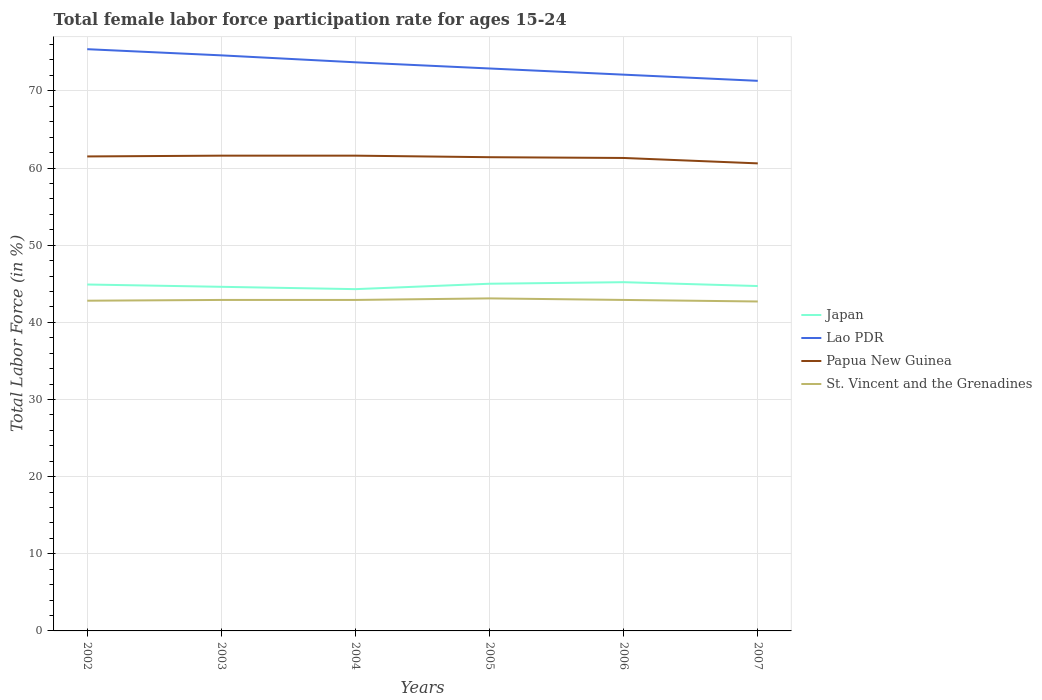How many different coloured lines are there?
Make the answer very short. 4. Across all years, what is the maximum female labor force participation rate in Japan?
Offer a very short reply. 44.3. What is the difference between the highest and the second highest female labor force participation rate in Lao PDR?
Keep it short and to the point. 4.1. Is the female labor force participation rate in St. Vincent and the Grenadines strictly greater than the female labor force participation rate in Papua New Guinea over the years?
Ensure brevity in your answer.  Yes. How many lines are there?
Ensure brevity in your answer.  4. Are the values on the major ticks of Y-axis written in scientific E-notation?
Your answer should be compact. No. Does the graph contain grids?
Make the answer very short. Yes. How many legend labels are there?
Provide a succinct answer. 4. How are the legend labels stacked?
Your answer should be very brief. Vertical. What is the title of the graph?
Offer a terse response. Total female labor force participation rate for ages 15-24. Does "Oman" appear as one of the legend labels in the graph?
Your answer should be very brief. No. What is the Total Labor Force (in %) of Japan in 2002?
Ensure brevity in your answer.  44.9. What is the Total Labor Force (in %) in Lao PDR in 2002?
Your answer should be very brief. 75.4. What is the Total Labor Force (in %) in Papua New Guinea in 2002?
Offer a very short reply. 61.5. What is the Total Labor Force (in %) in St. Vincent and the Grenadines in 2002?
Keep it short and to the point. 42.8. What is the Total Labor Force (in %) in Japan in 2003?
Make the answer very short. 44.6. What is the Total Labor Force (in %) of Lao PDR in 2003?
Ensure brevity in your answer.  74.6. What is the Total Labor Force (in %) in Papua New Guinea in 2003?
Offer a very short reply. 61.6. What is the Total Labor Force (in %) of St. Vincent and the Grenadines in 2003?
Offer a terse response. 42.9. What is the Total Labor Force (in %) of Japan in 2004?
Provide a short and direct response. 44.3. What is the Total Labor Force (in %) of Lao PDR in 2004?
Offer a very short reply. 73.7. What is the Total Labor Force (in %) in Papua New Guinea in 2004?
Provide a short and direct response. 61.6. What is the Total Labor Force (in %) in St. Vincent and the Grenadines in 2004?
Your answer should be compact. 42.9. What is the Total Labor Force (in %) in Japan in 2005?
Provide a succinct answer. 45. What is the Total Labor Force (in %) in Lao PDR in 2005?
Offer a terse response. 72.9. What is the Total Labor Force (in %) in Papua New Guinea in 2005?
Keep it short and to the point. 61.4. What is the Total Labor Force (in %) in St. Vincent and the Grenadines in 2005?
Your answer should be very brief. 43.1. What is the Total Labor Force (in %) of Japan in 2006?
Offer a very short reply. 45.2. What is the Total Labor Force (in %) in Lao PDR in 2006?
Keep it short and to the point. 72.1. What is the Total Labor Force (in %) in Papua New Guinea in 2006?
Make the answer very short. 61.3. What is the Total Labor Force (in %) of St. Vincent and the Grenadines in 2006?
Provide a succinct answer. 42.9. What is the Total Labor Force (in %) of Japan in 2007?
Offer a terse response. 44.7. What is the Total Labor Force (in %) of Lao PDR in 2007?
Offer a very short reply. 71.3. What is the Total Labor Force (in %) in Papua New Guinea in 2007?
Ensure brevity in your answer.  60.6. What is the Total Labor Force (in %) of St. Vincent and the Grenadines in 2007?
Your answer should be compact. 42.7. Across all years, what is the maximum Total Labor Force (in %) in Japan?
Your response must be concise. 45.2. Across all years, what is the maximum Total Labor Force (in %) in Lao PDR?
Offer a terse response. 75.4. Across all years, what is the maximum Total Labor Force (in %) in Papua New Guinea?
Keep it short and to the point. 61.6. Across all years, what is the maximum Total Labor Force (in %) in St. Vincent and the Grenadines?
Offer a very short reply. 43.1. Across all years, what is the minimum Total Labor Force (in %) of Japan?
Offer a terse response. 44.3. Across all years, what is the minimum Total Labor Force (in %) in Lao PDR?
Make the answer very short. 71.3. Across all years, what is the minimum Total Labor Force (in %) of Papua New Guinea?
Give a very brief answer. 60.6. Across all years, what is the minimum Total Labor Force (in %) in St. Vincent and the Grenadines?
Make the answer very short. 42.7. What is the total Total Labor Force (in %) of Japan in the graph?
Make the answer very short. 268.7. What is the total Total Labor Force (in %) in Lao PDR in the graph?
Give a very brief answer. 440. What is the total Total Labor Force (in %) of Papua New Guinea in the graph?
Offer a terse response. 368. What is the total Total Labor Force (in %) of St. Vincent and the Grenadines in the graph?
Keep it short and to the point. 257.3. What is the difference between the Total Labor Force (in %) of Japan in 2002 and that in 2003?
Keep it short and to the point. 0.3. What is the difference between the Total Labor Force (in %) in Lao PDR in 2002 and that in 2003?
Make the answer very short. 0.8. What is the difference between the Total Labor Force (in %) in St. Vincent and the Grenadines in 2002 and that in 2003?
Offer a very short reply. -0.1. What is the difference between the Total Labor Force (in %) of Japan in 2002 and that in 2004?
Ensure brevity in your answer.  0.6. What is the difference between the Total Labor Force (in %) in Lao PDR in 2002 and that in 2004?
Your answer should be compact. 1.7. What is the difference between the Total Labor Force (in %) of Papua New Guinea in 2002 and that in 2004?
Your answer should be very brief. -0.1. What is the difference between the Total Labor Force (in %) in Japan in 2002 and that in 2006?
Keep it short and to the point. -0.3. What is the difference between the Total Labor Force (in %) in Lao PDR in 2002 and that in 2006?
Offer a terse response. 3.3. What is the difference between the Total Labor Force (in %) of Papua New Guinea in 2002 and that in 2006?
Ensure brevity in your answer.  0.2. What is the difference between the Total Labor Force (in %) of Papua New Guinea in 2002 and that in 2007?
Ensure brevity in your answer.  0.9. What is the difference between the Total Labor Force (in %) in Japan in 2003 and that in 2004?
Give a very brief answer. 0.3. What is the difference between the Total Labor Force (in %) in Lao PDR in 2003 and that in 2004?
Offer a terse response. 0.9. What is the difference between the Total Labor Force (in %) in Papua New Guinea in 2003 and that in 2004?
Make the answer very short. 0. What is the difference between the Total Labor Force (in %) in St. Vincent and the Grenadines in 2003 and that in 2004?
Your answer should be compact. 0. What is the difference between the Total Labor Force (in %) in Japan in 2003 and that in 2005?
Give a very brief answer. -0.4. What is the difference between the Total Labor Force (in %) in Lao PDR in 2003 and that in 2005?
Your answer should be compact. 1.7. What is the difference between the Total Labor Force (in %) of Lao PDR in 2003 and that in 2006?
Provide a succinct answer. 2.5. What is the difference between the Total Labor Force (in %) in Papua New Guinea in 2003 and that in 2006?
Your answer should be compact. 0.3. What is the difference between the Total Labor Force (in %) of Japan in 2003 and that in 2007?
Provide a short and direct response. -0.1. What is the difference between the Total Labor Force (in %) of St. Vincent and the Grenadines in 2003 and that in 2007?
Provide a short and direct response. 0.2. What is the difference between the Total Labor Force (in %) in Japan in 2004 and that in 2005?
Ensure brevity in your answer.  -0.7. What is the difference between the Total Labor Force (in %) of Lao PDR in 2004 and that in 2005?
Offer a very short reply. 0.8. What is the difference between the Total Labor Force (in %) of Papua New Guinea in 2004 and that in 2005?
Provide a short and direct response. 0.2. What is the difference between the Total Labor Force (in %) in St. Vincent and the Grenadines in 2004 and that in 2005?
Ensure brevity in your answer.  -0.2. What is the difference between the Total Labor Force (in %) of Japan in 2004 and that in 2006?
Make the answer very short. -0.9. What is the difference between the Total Labor Force (in %) in Papua New Guinea in 2004 and that in 2006?
Keep it short and to the point. 0.3. What is the difference between the Total Labor Force (in %) in St. Vincent and the Grenadines in 2004 and that in 2006?
Your response must be concise. 0. What is the difference between the Total Labor Force (in %) of Japan in 2004 and that in 2007?
Offer a very short reply. -0.4. What is the difference between the Total Labor Force (in %) of St. Vincent and the Grenadines in 2004 and that in 2007?
Provide a short and direct response. 0.2. What is the difference between the Total Labor Force (in %) in Japan in 2005 and that in 2006?
Ensure brevity in your answer.  -0.2. What is the difference between the Total Labor Force (in %) of Papua New Guinea in 2005 and that in 2006?
Keep it short and to the point. 0.1. What is the difference between the Total Labor Force (in %) of St. Vincent and the Grenadines in 2005 and that in 2006?
Give a very brief answer. 0.2. What is the difference between the Total Labor Force (in %) of Japan in 2005 and that in 2007?
Make the answer very short. 0.3. What is the difference between the Total Labor Force (in %) of St. Vincent and the Grenadines in 2005 and that in 2007?
Provide a short and direct response. 0.4. What is the difference between the Total Labor Force (in %) of Japan in 2006 and that in 2007?
Your answer should be very brief. 0.5. What is the difference between the Total Labor Force (in %) of Japan in 2002 and the Total Labor Force (in %) of Lao PDR in 2003?
Offer a very short reply. -29.7. What is the difference between the Total Labor Force (in %) of Japan in 2002 and the Total Labor Force (in %) of Papua New Guinea in 2003?
Offer a very short reply. -16.7. What is the difference between the Total Labor Force (in %) of Japan in 2002 and the Total Labor Force (in %) of St. Vincent and the Grenadines in 2003?
Make the answer very short. 2. What is the difference between the Total Labor Force (in %) in Lao PDR in 2002 and the Total Labor Force (in %) in St. Vincent and the Grenadines in 2003?
Give a very brief answer. 32.5. What is the difference between the Total Labor Force (in %) of Papua New Guinea in 2002 and the Total Labor Force (in %) of St. Vincent and the Grenadines in 2003?
Keep it short and to the point. 18.6. What is the difference between the Total Labor Force (in %) in Japan in 2002 and the Total Labor Force (in %) in Lao PDR in 2004?
Your answer should be compact. -28.8. What is the difference between the Total Labor Force (in %) in Japan in 2002 and the Total Labor Force (in %) in Papua New Guinea in 2004?
Provide a short and direct response. -16.7. What is the difference between the Total Labor Force (in %) of Japan in 2002 and the Total Labor Force (in %) of St. Vincent and the Grenadines in 2004?
Provide a short and direct response. 2. What is the difference between the Total Labor Force (in %) in Lao PDR in 2002 and the Total Labor Force (in %) in Papua New Guinea in 2004?
Make the answer very short. 13.8. What is the difference between the Total Labor Force (in %) of Lao PDR in 2002 and the Total Labor Force (in %) of St. Vincent and the Grenadines in 2004?
Your response must be concise. 32.5. What is the difference between the Total Labor Force (in %) of Japan in 2002 and the Total Labor Force (in %) of Papua New Guinea in 2005?
Your answer should be compact. -16.5. What is the difference between the Total Labor Force (in %) in Lao PDR in 2002 and the Total Labor Force (in %) in Papua New Guinea in 2005?
Your answer should be very brief. 14. What is the difference between the Total Labor Force (in %) of Lao PDR in 2002 and the Total Labor Force (in %) of St. Vincent and the Grenadines in 2005?
Provide a short and direct response. 32.3. What is the difference between the Total Labor Force (in %) in Japan in 2002 and the Total Labor Force (in %) in Lao PDR in 2006?
Keep it short and to the point. -27.2. What is the difference between the Total Labor Force (in %) of Japan in 2002 and the Total Labor Force (in %) of Papua New Guinea in 2006?
Make the answer very short. -16.4. What is the difference between the Total Labor Force (in %) of Lao PDR in 2002 and the Total Labor Force (in %) of Papua New Guinea in 2006?
Your response must be concise. 14.1. What is the difference between the Total Labor Force (in %) of Lao PDR in 2002 and the Total Labor Force (in %) of St. Vincent and the Grenadines in 2006?
Keep it short and to the point. 32.5. What is the difference between the Total Labor Force (in %) in Papua New Guinea in 2002 and the Total Labor Force (in %) in St. Vincent and the Grenadines in 2006?
Your answer should be compact. 18.6. What is the difference between the Total Labor Force (in %) of Japan in 2002 and the Total Labor Force (in %) of Lao PDR in 2007?
Offer a very short reply. -26.4. What is the difference between the Total Labor Force (in %) of Japan in 2002 and the Total Labor Force (in %) of Papua New Guinea in 2007?
Offer a terse response. -15.7. What is the difference between the Total Labor Force (in %) in Japan in 2002 and the Total Labor Force (in %) in St. Vincent and the Grenadines in 2007?
Keep it short and to the point. 2.2. What is the difference between the Total Labor Force (in %) in Lao PDR in 2002 and the Total Labor Force (in %) in St. Vincent and the Grenadines in 2007?
Provide a succinct answer. 32.7. What is the difference between the Total Labor Force (in %) in Japan in 2003 and the Total Labor Force (in %) in Lao PDR in 2004?
Offer a terse response. -29.1. What is the difference between the Total Labor Force (in %) in Japan in 2003 and the Total Labor Force (in %) in Papua New Guinea in 2004?
Provide a succinct answer. -17. What is the difference between the Total Labor Force (in %) of Japan in 2003 and the Total Labor Force (in %) of St. Vincent and the Grenadines in 2004?
Make the answer very short. 1.7. What is the difference between the Total Labor Force (in %) in Lao PDR in 2003 and the Total Labor Force (in %) in Papua New Guinea in 2004?
Make the answer very short. 13. What is the difference between the Total Labor Force (in %) of Lao PDR in 2003 and the Total Labor Force (in %) of St. Vincent and the Grenadines in 2004?
Provide a succinct answer. 31.7. What is the difference between the Total Labor Force (in %) of Japan in 2003 and the Total Labor Force (in %) of Lao PDR in 2005?
Offer a terse response. -28.3. What is the difference between the Total Labor Force (in %) of Japan in 2003 and the Total Labor Force (in %) of Papua New Guinea in 2005?
Keep it short and to the point. -16.8. What is the difference between the Total Labor Force (in %) in Lao PDR in 2003 and the Total Labor Force (in %) in Papua New Guinea in 2005?
Your answer should be compact. 13.2. What is the difference between the Total Labor Force (in %) in Lao PDR in 2003 and the Total Labor Force (in %) in St. Vincent and the Grenadines in 2005?
Provide a succinct answer. 31.5. What is the difference between the Total Labor Force (in %) in Japan in 2003 and the Total Labor Force (in %) in Lao PDR in 2006?
Offer a very short reply. -27.5. What is the difference between the Total Labor Force (in %) of Japan in 2003 and the Total Labor Force (in %) of Papua New Guinea in 2006?
Provide a succinct answer. -16.7. What is the difference between the Total Labor Force (in %) of Japan in 2003 and the Total Labor Force (in %) of St. Vincent and the Grenadines in 2006?
Provide a succinct answer. 1.7. What is the difference between the Total Labor Force (in %) in Lao PDR in 2003 and the Total Labor Force (in %) in St. Vincent and the Grenadines in 2006?
Ensure brevity in your answer.  31.7. What is the difference between the Total Labor Force (in %) in Japan in 2003 and the Total Labor Force (in %) in Lao PDR in 2007?
Provide a short and direct response. -26.7. What is the difference between the Total Labor Force (in %) in Japan in 2003 and the Total Labor Force (in %) in Papua New Guinea in 2007?
Offer a terse response. -16. What is the difference between the Total Labor Force (in %) in Lao PDR in 2003 and the Total Labor Force (in %) in St. Vincent and the Grenadines in 2007?
Ensure brevity in your answer.  31.9. What is the difference between the Total Labor Force (in %) of Japan in 2004 and the Total Labor Force (in %) of Lao PDR in 2005?
Your answer should be very brief. -28.6. What is the difference between the Total Labor Force (in %) in Japan in 2004 and the Total Labor Force (in %) in Papua New Guinea in 2005?
Keep it short and to the point. -17.1. What is the difference between the Total Labor Force (in %) in Japan in 2004 and the Total Labor Force (in %) in St. Vincent and the Grenadines in 2005?
Offer a terse response. 1.2. What is the difference between the Total Labor Force (in %) of Lao PDR in 2004 and the Total Labor Force (in %) of St. Vincent and the Grenadines in 2005?
Ensure brevity in your answer.  30.6. What is the difference between the Total Labor Force (in %) of Papua New Guinea in 2004 and the Total Labor Force (in %) of St. Vincent and the Grenadines in 2005?
Your answer should be compact. 18.5. What is the difference between the Total Labor Force (in %) of Japan in 2004 and the Total Labor Force (in %) of Lao PDR in 2006?
Ensure brevity in your answer.  -27.8. What is the difference between the Total Labor Force (in %) of Lao PDR in 2004 and the Total Labor Force (in %) of Papua New Guinea in 2006?
Provide a succinct answer. 12.4. What is the difference between the Total Labor Force (in %) in Lao PDR in 2004 and the Total Labor Force (in %) in St. Vincent and the Grenadines in 2006?
Offer a terse response. 30.8. What is the difference between the Total Labor Force (in %) of Japan in 2004 and the Total Labor Force (in %) of Lao PDR in 2007?
Your answer should be very brief. -27. What is the difference between the Total Labor Force (in %) in Japan in 2004 and the Total Labor Force (in %) in Papua New Guinea in 2007?
Offer a very short reply. -16.3. What is the difference between the Total Labor Force (in %) of Japan in 2004 and the Total Labor Force (in %) of St. Vincent and the Grenadines in 2007?
Give a very brief answer. 1.6. What is the difference between the Total Labor Force (in %) of Lao PDR in 2004 and the Total Labor Force (in %) of St. Vincent and the Grenadines in 2007?
Provide a short and direct response. 31. What is the difference between the Total Labor Force (in %) in Papua New Guinea in 2004 and the Total Labor Force (in %) in St. Vincent and the Grenadines in 2007?
Your answer should be compact. 18.9. What is the difference between the Total Labor Force (in %) of Japan in 2005 and the Total Labor Force (in %) of Lao PDR in 2006?
Offer a very short reply. -27.1. What is the difference between the Total Labor Force (in %) in Japan in 2005 and the Total Labor Force (in %) in Papua New Guinea in 2006?
Your answer should be very brief. -16.3. What is the difference between the Total Labor Force (in %) of Japan in 2005 and the Total Labor Force (in %) of St. Vincent and the Grenadines in 2006?
Ensure brevity in your answer.  2.1. What is the difference between the Total Labor Force (in %) of Papua New Guinea in 2005 and the Total Labor Force (in %) of St. Vincent and the Grenadines in 2006?
Make the answer very short. 18.5. What is the difference between the Total Labor Force (in %) in Japan in 2005 and the Total Labor Force (in %) in Lao PDR in 2007?
Your response must be concise. -26.3. What is the difference between the Total Labor Force (in %) in Japan in 2005 and the Total Labor Force (in %) in Papua New Guinea in 2007?
Provide a succinct answer. -15.6. What is the difference between the Total Labor Force (in %) of Japan in 2005 and the Total Labor Force (in %) of St. Vincent and the Grenadines in 2007?
Make the answer very short. 2.3. What is the difference between the Total Labor Force (in %) in Lao PDR in 2005 and the Total Labor Force (in %) in Papua New Guinea in 2007?
Your response must be concise. 12.3. What is the difference between the Total Labor Force (in %) in Lao PDR in 2005 and the Total Labor Force (in %) in St. Vincent and the Grenadines in 2007?
Your answer should be compact. 30.2. What is the difference between the Total Labor Force (in %) in Papua New Guinea in 2005 and the Total Labor Force (in %) in St. Vincent and the Grenadines in 2007?
Offer a very short reply. 18.7. What is the difference between the Total Labor Force (in %) of Japan in 2006 and the Total Labor Force (in %) of Lao PDR in 2007?
Ensure brevity in your answer.  -26.1. What is the difference between the Total Labor Force (in %) in Japan in 2006 and the Total Labor Force (in %) in Papua New Guinea in 2007?
Your answer should be very brief. -15.4. What is the difference between the Total Labor Force (in %) in Japan in 2006 and the Total Labor Force (in %) in St. Vincent and the Grenadines in 2007?
Your response must be concise. 2.5. What is the difference between the Total Labor Force (in %) in Lao PDR in 2006 and the Total Labor Force (in %) in St. Vincent and the Grenadines in 2007?
Your response must be concise. 29.4. What is the difference between the Total Labor Force (in %) of Papua New Guinea in 2006 and the Total Labor Force (in %) of St. Vincent and the Grenadines in 2007?
Offer a terse response. 18.6. What is the average Total Labor Force (in %) in Japan per year?
Make the answer very short. 44.78. What is the average Total Labor Force (in %) in Lao PDR per year?
Your answer should be very brief. 73.33. What is the average Total Labor Force (in %) in Papua New Guinea per year?
Your response must be concise. 61.33. What is the average Total Labor Force (in %) in St. Vincent and the Grenadines per year?
Your response must be concise. 42.88. In the year 2002, what is the difference between the Total Labor Force (in %) in Japan and Total Labor Force (in %) in Lao PDR?
Make the answer very short. -30.5. In the year 2002, what is the difference between the Total Labor Force (in %) in Japan and Total Labor Force (in %) in Papua New Guinea?
Your answer should be compact. -16.6. In the year 2002, what is the difference between the Total Labor Force (in %) in Lao PDR and Total Labor Force (in %) in Papua New Guinea?
Ensure brevity in your answer.  13.9. In the year 2002, what is the difference between the Total Labor Force (in %) of Lao PDR and Total Labor Force (in %) of St. Vincent and the Grenadines?
Offer a very short reply. 32.6. In the year 2002, what is the difference between the Total Labor Force (in %) of Papua New Guinea and Total Labor Force (in %) of St. Vincent and the Grenadines?
Ensure brevity in your answer.  18.7. In the year 2003, what is the difference between the Total Labor Force (in %) in Japan and Total Labor Force (in %) in Lao PDR?
Your response must be concise. -30. In the year 2003, what is the difference between the Total Labor Force (in %) of Japan and Total Labor Force (in %) of St. Vincent and the Grenadines?
Offer a very short reply. 1.7. In the year 2003, what is the difference between the Total Labor Force (in %) of Lao PDR and Total Labor Force (in %) of St. Vincent and the Grenadines?
Give a very brief answer. 31.7. In the year 2004, what is the difference between the Total Labor Force (in %) in Japan and Total Labor Force (in %) in Lao PDR?
Your answer should be very brief. -29.4. In the year 2004, what is the difference between the Total Labor Force (in %) in Japan and Total Labor Force (in %) in Papua New Guinea?
Provide a short and direct response. -17.3. In the year 2004, what is the difference between the Total Labor Force (in %) in Lao PDR and Total Labor Force (in %) in St. Vincent and the Grenadines?
Ensure brevity in your answer.  30.8. In the year 2004, what is the difference between the Total Labor Force (in %) of Papua New Guinea and Total Labor Force (in %) of St. Vincent and the Grenadines?
Provide a short and direct response. 18.7. In the year 2005, what is the difference between the Total Labor Force (in %) in Japan and Total Labor Force (in %) in Lao PDR?
Provide a succinct answer. -27.9. In the year 2005, what is the difference between the Total Labor Force (in %) in Japan and Total Labor Force (in %) in Papua New Guinea?
Your answer should be compact. -16.4. In the year 2005, what is the difference between the Total Labor Force (in %) of Lao PDR and Total Labor Force (in %) of Papua New Guinea?
Give a very brief answer. 11.5. In the year 2005, what is the difference between the Total Labor Force (in %) in Lao PDR and Total Labor Force (in %) in St. Vincent and the Grenadines?
Your answer should be compact. 29.8. In the year 2006, what is the difference between the Total Labor Force (in %) of Japan and Total Labor Force (in %) of Lao PDR?
Your response must be concise. -26.9. In the year 2006, what is the difference between the Total Labor Force (in %) in Japan and Total Labor Force (in %) in Papua New Guinea?
Provide a short and direct response. -16.1. In the year 2006, what is the difference between the Total Labor Force (in %) of Lao PDR and Total Labor Force (in %) of St. Vincent and the Grenadines?
Ensure brevity in your answer.  29.2. In the year 2007, what is the difference between the Total Labor Force (in %) in Japan and Total Labor Force (in %) in Lao PDR?
Keep it short and to the point. -26.6. In the year 2007, what is the difference between the Total Labor Force (in %) in Japan and Total Labor Force (in %) in Papua New Guinea?
Make the answer very short. -15.9. In the year 2007, what is the difference between the Total Labor Force (in %) of Japan and Total Labor Force (in %) of St. Vincent and the Grenadines?
Offer a very short reply. 2. In the year 2007, what is the difference between the Total Labor Force (in %) of Lao PDR and Total Labor Force (in %) of St. Vincent and the Grenadines?
Keep it short and to the point. 28.6. In the year 2007, what is the difference between the Total Labor Force (in %) in Papua New Guinea and Total Labor Force (in %) in St. Vincent and the Grenadines?
Your answer should be very brief. 17.9. What is the ratio of the Total Labor Force (in %) of Lao PDR in 2002 to that in 2003?
Provide a succinct answer. 1.01. What is the ratio of the Total Labor Force (in %) of St. Vincent and the Grenadines in 2002 to that in 2003?
Keep it short and to the point. 1. What is the ratio of the Total Labor Force (in %) of Japan in 2002 to that in 2004?
Give a very brief answer. 1.01. What is the ratio of the Total Labor Force (in %) in Lao PDR in 2002 to that in 2004?
Offer a very short reply. 1.02. What is the ratio of the Total Labor Force (in %) of Papua New Guinea in 2002 to that in 2004?
Your answer should be very brief. 1. What is the ratio of the Total Labor Force (in %) in Japan in 2002 to that in 2005?
Your response must be concise. 1. What is the ratio of the Total Labor Force (in %) of Lao PDR in 2002 to that in 2005?
Make the answer very short. 1.03. What is the ratio of the Total Labor Force (in %) of St. Vincent and the Grenadines in 2002 to that in 2005?
Keep it short and to the point. 0.99. What is the ratio of the Total Labor Force (in %) in Lao PDR in 2002 to that in 2006?
Your response must be concise. 1.05. What is the ratio of the Total Labor Force (in %) in St. Vincent and the Grenadines in 2002 to that in 2006?
Your response must be concise. 1. What is the ratio of the Total Labor Force (in %) of Japan in 2002 to that in 2007?
Give a very brief answer. 1. What is the ratio of the Total Labor Force (in %) of Lao PDR in 2002 to that in 2007?
Keep it short and to the point. 1.06. What is the ratio of the Total Labor Force (in %) of Papua New Guinea in 2002 to that in 2007?
Offer a very short reply. 1.01. What is the ratio of the Total Labor Force (in %) of St. Vincent and the Grenadines in 2002 to that in 2007?
Your answer should be compact. 1. What is the ratio of the Total Labor Force (in %) of Japan in 2003 to that in 2004?
Keep it short and to the point. 1.01. What is the ratio of the Total Labor Force (in %) in Lao PDR in 2003 to that in 2004?
Offer a terse response. 1.01. What is the ratio of the Total Labor Force (in %) in Japan in 2003 to that in 2005?
Make the answer very short. 0.99. What is the ratio of the Total Labor Force (in %) in Lao PDR in 2003 to that in 2005?
Provide a succinct answer. 1.02. What is the ratio of the Total Labor Force (in %) of Japan in 2003 to that in 2006?
Provide a short and direct response. 0.99. What is the ratio of the Total Labor Force (in %) of Lao PDR in 2003 to that in 2006?
Provide a succinct answer. 1.03. What is the ratio of the Total Labor Force (in %) in Papua New Guinea in 2003 to that in 2006?
Your answer should be compact. 1. What is the ratio of the Total Labor Force (in %) in Lao PDR in 2003 to that in 2007?
Make the answer very short. 1.05. What is the ratio of the Total Labor Force (in %) of Papua New Guinea in 2003 to that in 2007?
Offer a terse response. 1.02. What is the ratio of the Total Labor Force (in %) of St. Vincent and the Grenadines in 2003 to that in 2007?
Make the answer very short. 1. What is the ratio of the Total Labor Force (in %) of Japan in 2004 to that in 2005?
Ensure brevity in your answer.  0.98. What is the ratio of the Total Labor Force (in %) in Lao PDR in 2004 to that in 2005?
Offer a terse response. 1.01. What is the ratio of the Total Labor Force (in %) of Japan in 2004 to that in 2006?
Your answer should be very brief. 0.98. What is the ratio of the Total Labor Force (in %) in Lao PDR in 2004 to that in 2006?
Provide a succinct answer. 1.02. What is the ratio of the Total Labor Force (in %) in Lao PDR in 2004 to that in 2007?
Give a very brief answer. 1.03. What is the ratio of the Total Labor Force (in %) of Papua New Guinea in 2004 to that in 2007?
Provide a succinct answer. 1.02. What is the ratio of the Total Labor Force (in %) in St. Vincent and the Grenadines in 2004 to that in 2007?
Provide a short and direct response. 1. What is the ratio of the Total Labor Force (in %) in Japan in 2005 to that in 2006?
Your answer should be compact. 1. What is the ratio of the Total Labor Force (in %) in Lao PDR in 2005 to that in 2006?
Offer a very short reply. 1.01. What is the ratio of the Total Labor Force (in %) of Lao PDR in 2005 to that in 2007?
Ensure brevity in your answer.  1.02. What is the ratio of the Total Labor Force (in %) in Papua New Guinea in 2005 to that in 2007?
Offer a terse response. 1.01. What is the ratio of the Total Labor Force (in %) of St. Vincent and the Grenadines in 2005 to that in 2007?
Give a very brief answer. 1.01. What is the ratio of the Total Labor Force (in %) of Japan in 2006 to that in 2007?
Your answer should be compact. 1.01. What is the ratio of the Total Labor Force (in %) of Lao PDR in 2006 to that in 2007?
Offer a terse response. 1.01. What is the ratio of the Total Labor Force (in %) in Papua New Guinea in 2006 to that in 2007?
Ensure brevity in your answer.  1.01. What is the difference between the highest and the second highest Total Labor Force (in %) in Lao PDR?
Provide a short and direct response. 0.8. What is the difference between the highest and the second highest Total Labor Force (in %) of St. Vincent and the Grenadines?
Give a very brief answer. 0.2. 